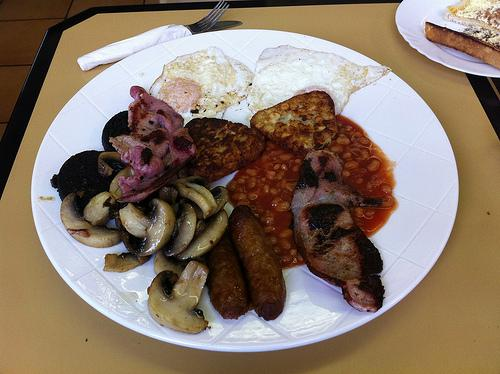Question: what is on the plate in the upper right corner?
Choices:
A. A pizza slice.
B. Toast.
C. Meatballs.
D. A Sandwich.
Answer with the letter. Answer: B Question: what color is the plate?
Choices:
A. Blue.
B. White.
C. Red.
D. Green.
Answer with the letter. Answer: B Question: when was the picture taken?
Choices:
A. Playtime.
B. Bedtime.
C. Game time.
D. Mealtime.
Answer with the letter. Answer: D Question: how many plates are in the picture?
Choices:
A. Three.
B. One.
C. Two.
D. Five.
Answer with the letter. Answer: C Question: what are the white things at the top of the front most plate?
Choices:
A. Eggs.
B. White chocolate.
C. Mozzarella.
D. Parmesan  cheese.
Answer with the letter. Answer: A Question: what are the brown-gray vegetables on the front most plate?
Choices:
A. Potatoes.
B. Dried ginger.
C. Mushrooms.
D. Squash.
Answer with the letter. Answer: C 